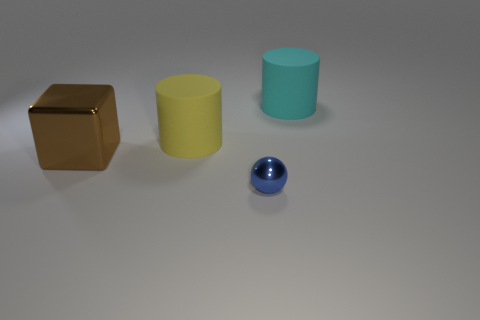Add 1 small blue spheres. How many objects exist? 5 Subtract all blocks. How many objects are left? 3 Add 4 large objects. How many large objects are left? 7 Add 2 rubber things. How many rubber things exist? 4 Subtract 0 red blocks. How many objects are left? 4 Subtract all large brown shiny cubes. Subtract all cylinders. How many objects are left? 1 